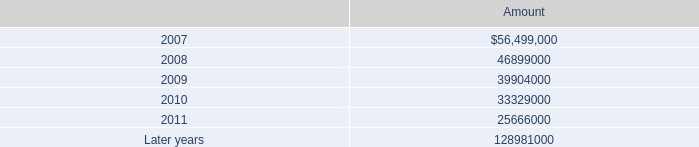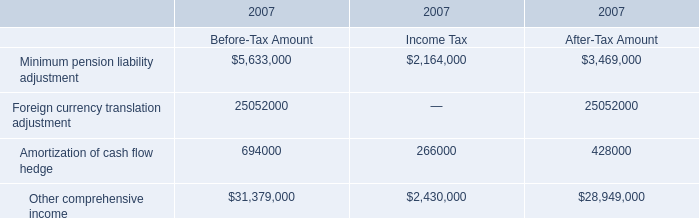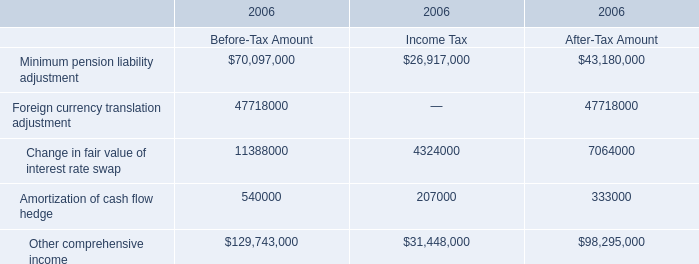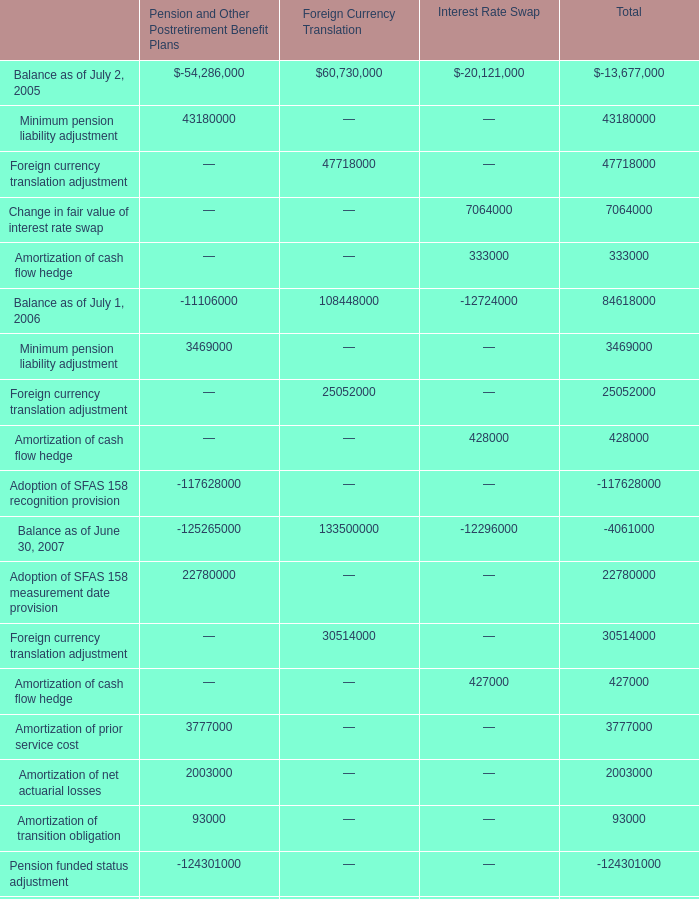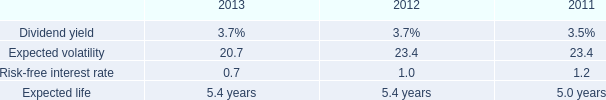How much is the Income Tax for Other comprehensive income in 2006 more than the Income Tax for Amortization of cash flow hedge in 2006? 
Computations: (31448000 - 207000)
Answer: 31241000.0. 